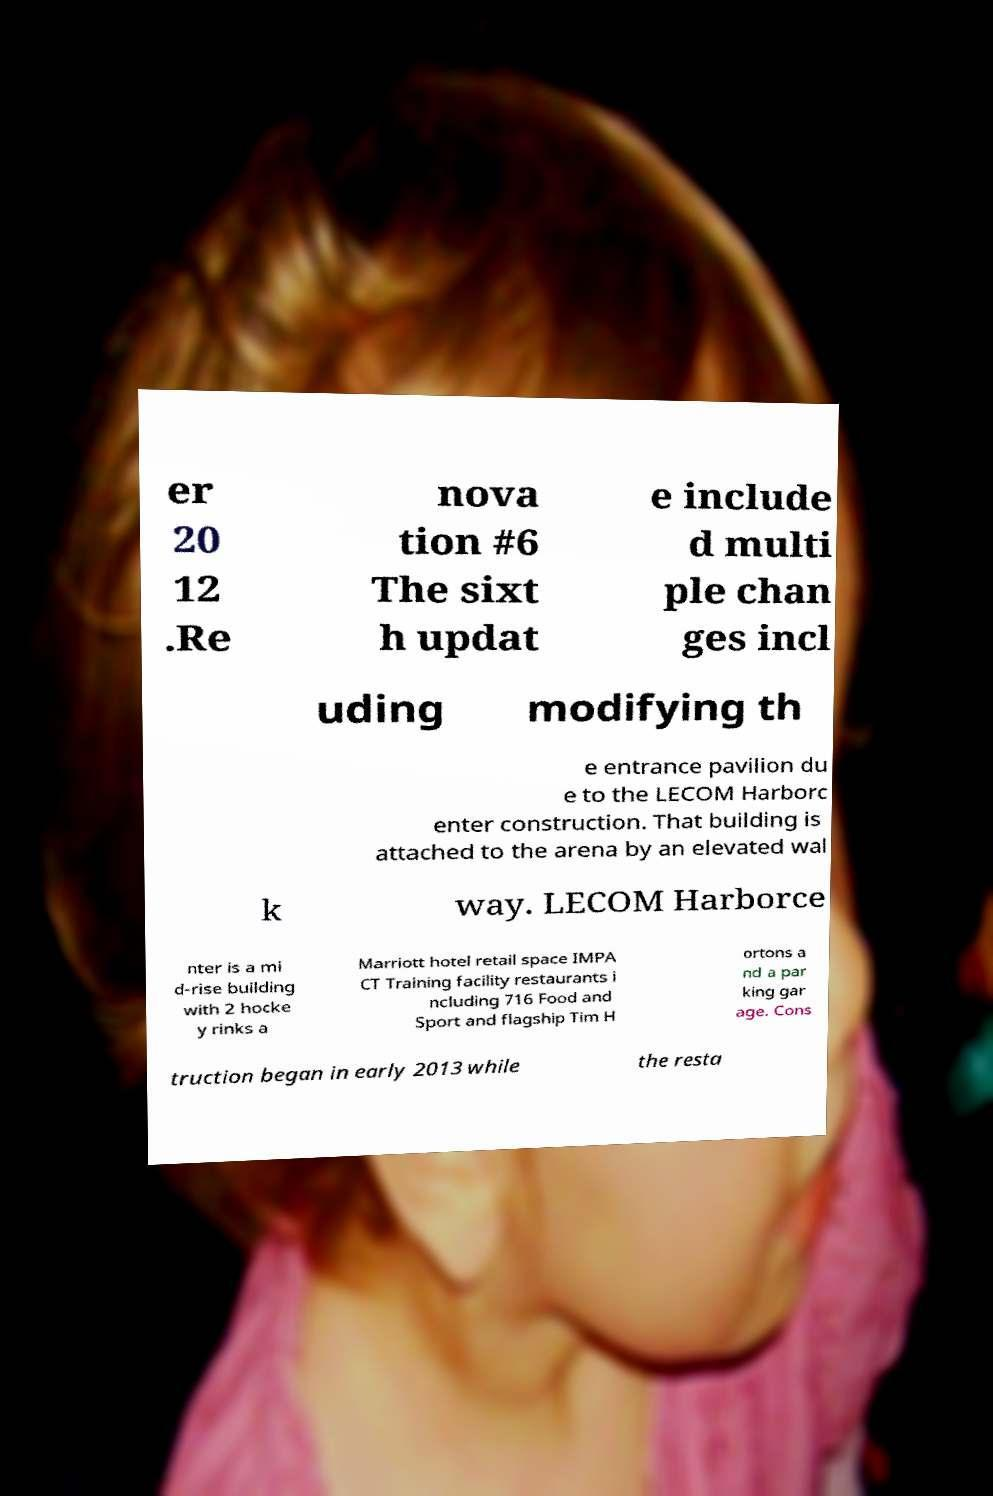Please identify and transcribe the text found in this image. er 20 12 .Re nova tion #6 The sixt h updat e include d multi ple chan ges incl uding modifying th e entrance pavilion du e to the LECOM Harborc enter construction. That building is attached to the arena by an elevated wal k way. LECOM Harborce nter is a mi d-rise building with 2 hocke y rinks a Marriott hotel retail space IMPA CT Training facility restaurants i ncluding 716 Food and Sport and flagship Tim H ortons a nd a par king gar age. Cons truction began in early 2013 while the resta 